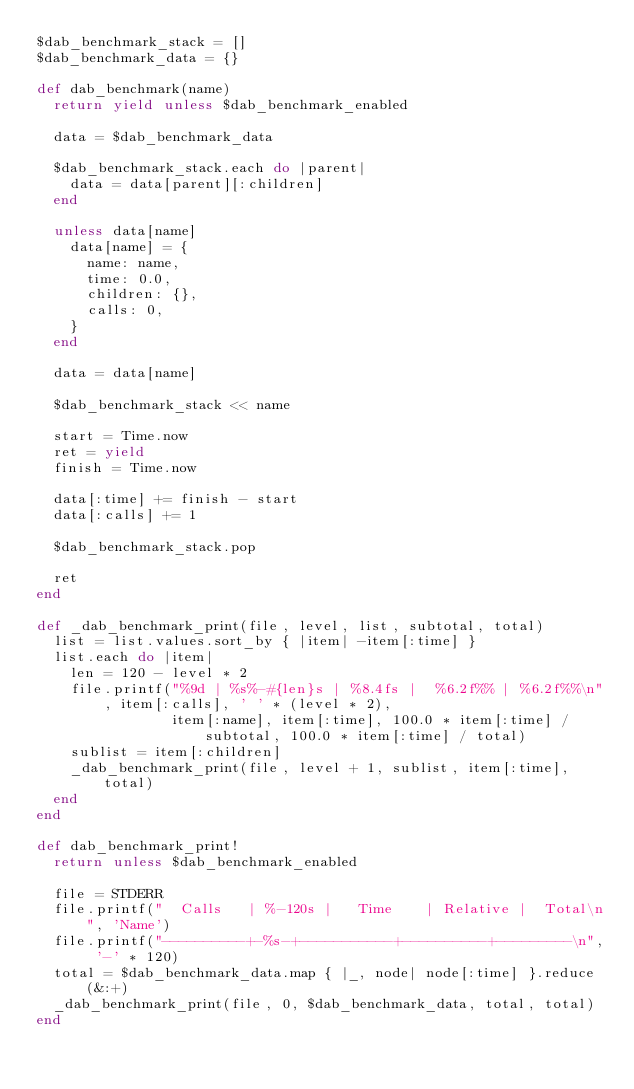<code> <loc_0><loc_0><loc_500><loc_500><_Ruby_>$dab_benchmark_stack = []
$dab_benchmark_data = {}

def dab_benchmark(name)
  return yield unless $dab_benchmark_enabled

  data = $dab_benchmark_data

  $dab_benchmark_stack.each do |parent|
    data = data[parent][:children]
  end

  unless data[name]
    data[name] = {
      name: name,
      time: 0.0,
      children: {},
      calls: 0,
    }
  end

  data = data[name]

  $dab_benchmark_stack << name

  start = Time.now
  ret = yield
  finish = Time.now

  data[:time] += finish - start
  data[:calls] += 1

  $dab_benchmark_stack.pop

  ret
end

def _dab_benchmark_print(file, level, list, subtotal, total)
  list = list.values.sort_by { |item| -item[:time] }
  list.each do |item|
    len = 120 - level * 2
    file.printf("%9d | %s%-#{len}s | %8.4fs |  %6.2f%% | %6.2f%%\n", item[:calls], ' ' * (level * 2),
                item[:name], item[:time], 100.0 * item[:time] / subtotal, 100.0 * item[:time] / total)
    sublist = item[:children]
    _dab_benchmark_print(file, level + 1, sublist, item[:time], total)
  end
end

def dab_benchmark_print!
  return unless $dab_benchmark_enabled

  file = STDERR
  file.printf("  Calls   | %-120s |   Time    | Relative |  Total\n", 'Name')
  file.printf("----------+-%s-+-----------+----------+---------\n", '-' * 120)
  total = $dab_benchmark_data.map { |_, node| node[:time] }.reduce(&:+)
  _dab_benchmark_print(file, 0, $dab_benchmark_data, total, total)
end
</code> 